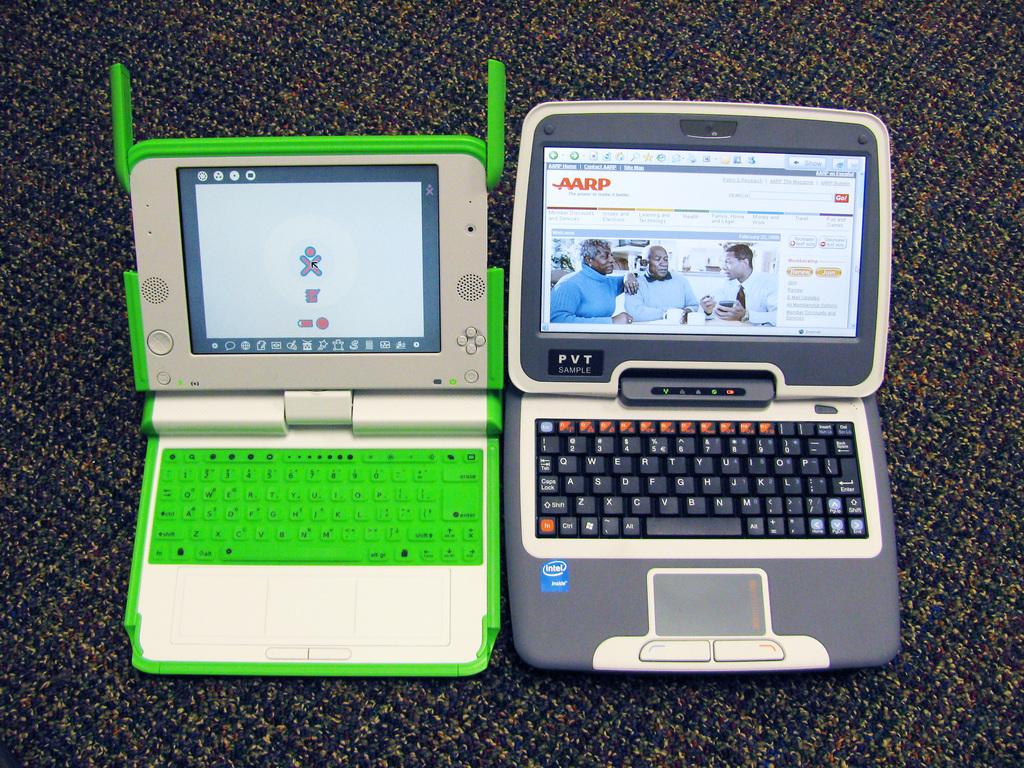What company is the website for on the grey laptop?
Make the answer very short. Aarp. 